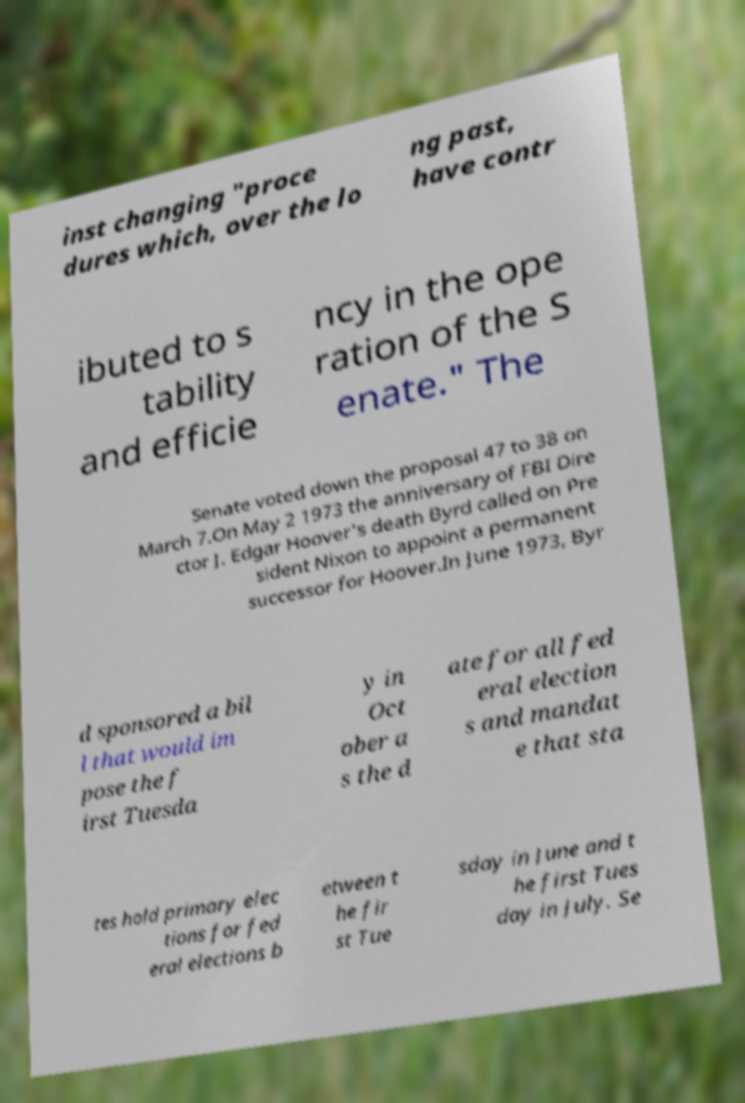Can you read and provide the text displayed in the image?This photo seems to have some interesting text. Can you extract and type it out for me? inst changing "proce dures which, over the lo ng past, have contr ibuted to s tability and efficie ncy in the ope ration of the S enate." The Senate voted down the proposal 47 to 38 on March 7.On May 2 1973 the anniversary of FBI Dire ctor J. Edgar Hoover's death Byrd called on Pre sident Nixon to appoint a permanent successor for Hoover.In June 1973, Byr d sponsored a bil l that would im pose the f irst Tuesda y in Oct ober a s the d ate for all fed eral election s and mandat e that sta tes hold primary elec tions for fed eral elections b etween t he fir st Tue sday in June and t he first Tues day in July. Se 